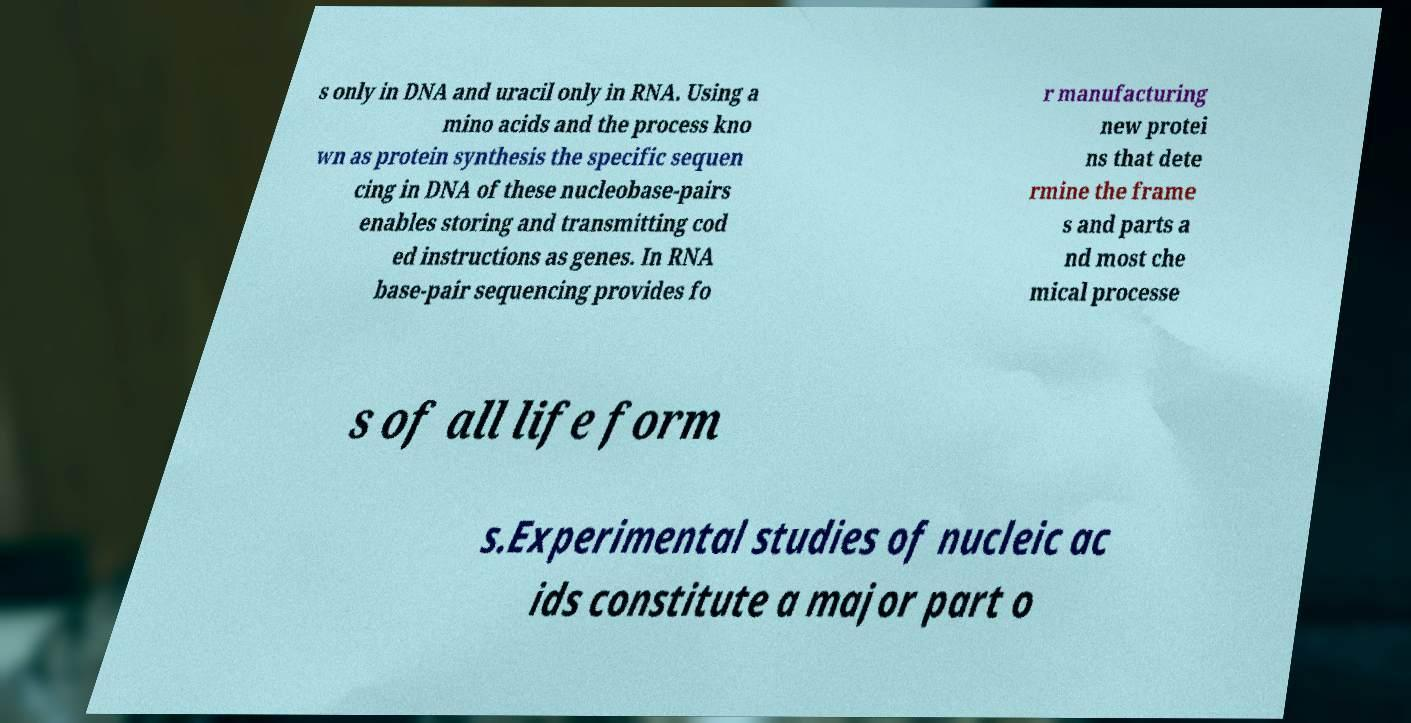Please read and relay the text visible in this image. What does it say? s only in DNA and uracil only in RNA. Using a mino acids and the process kno wn as protein synthesis the specific sequen cing in DNA of these nucleobase-pairs enables storing and transmitting cod ed instructions as genes. In RNA base-pair sequencing provides fo r manufacturing new protei ns that dete rmine the frame s and parts a nd most che mical processe s of all life form s.Experimental studies of nucleic ac ids constitute a major part o 